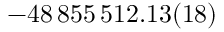<formula> <loc_0><loc_0><loc_500><loc_500>- 4 8 \, 8 5 5 \, 5 1 2 . 1 3 ( 1 8 )</formula> 